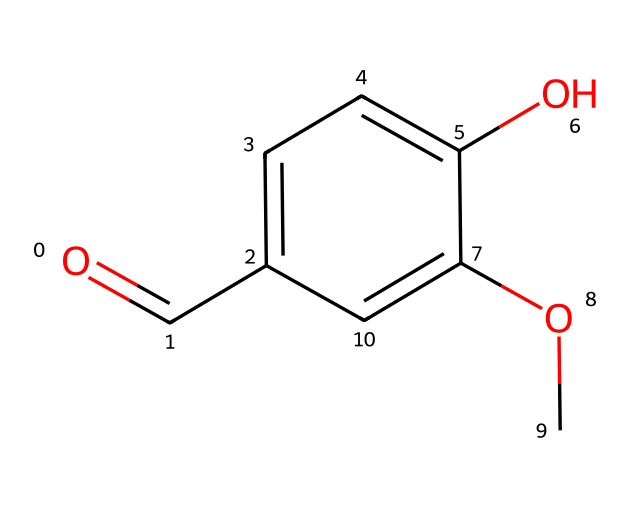how many carbon atoms are in the structure? By examining the SMILES representation, we can count the number of carbon (C) atoms. The structure comprises three carbon atoms in the aromatic ring and one carbon in the aldehyde functional group, totaling four carbon atoms.
Answer: four what functional group is present in vanillin? The SMILES representation indicates the presence of a carbonyl group (C=O) attached to a carbon atom, which qualifies it as an aldehyde functional group.
Answer: aldehyde what is the total number of oxygen atoms in vanillin? Inspecting the SMILES reveals two oxygen atoms: one in the aldehyde group and another in the methoxy group (-OCH3). Hence, there are two oxygen atoms present.
Answer: two how many double bonds are present in this molecule? In the provided SMILES, a single double bond is found in the carbonyl (C=O) of the aldehyde and not elsewhere in the structure. Thus, there is one double bond in total.
Answer: one what type of compound is vanillin classified as? Vanillin has both aromatic and aldehyde features; thus, it can be classified as an aromatic aldehyde based on its structure.
Answer: aromatic aldehyde what role does the aldehyde group play in the flavor of vanillin? The aldehyde group is responsible for the characteristic vanilla flavor and aroma, giving vanillin its signature taste profile.
Answer: flavor contributor how many hydrogen atoms can be deduced from the structure? From the SMILES representation, we can ascertain the total number of hydrogen atoms given the carbon atoms' bonding; specifically, counting the implicit hydrogens indicates there are six hydrogen atoms attached to the carbon structure.
Answer: six 